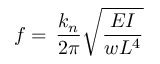<formula> <loc_0><loc_0><loc_500><loc_500>f = \, \frac { { { k _ { n } } } } { 2 \pi } \sqrt { \frac { E I } { { w { L ^ { 4 } } } } }</formula> 